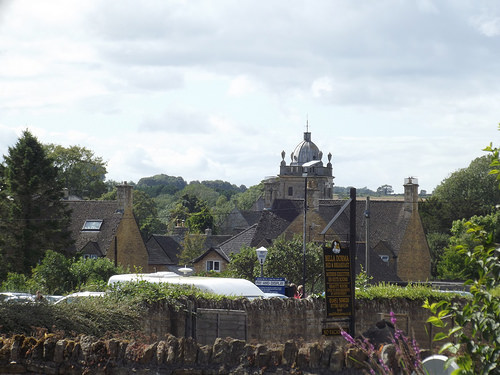<image>
Is the vehicle in front of the sign? No. The vehicle is not in front of the sign. The spatial positioning shows a different relationship between these objects. Is the gate above the wall? No. The gate is not positioned above the wall. The vertical arrangement shows a different relationship. 